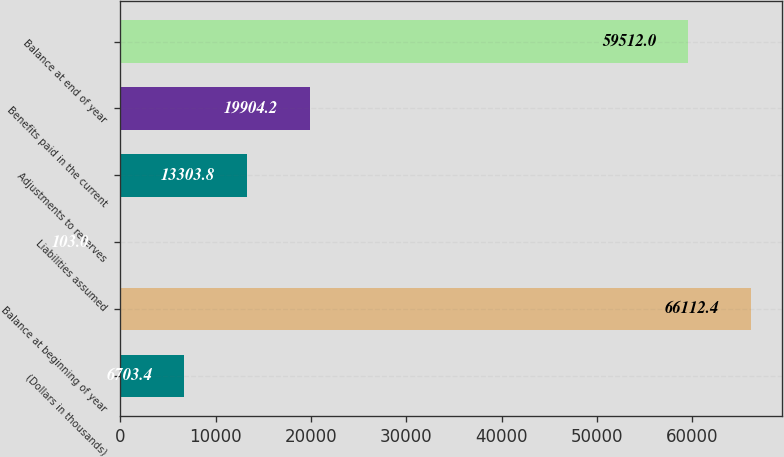Convert chart. <chart><loc_0><loc_0><loc_500><loc_500><bar_chart><fcel>(Dollars in thousands)<fcel>Balance at beginning of year<fcel>Liabilities assumed<fcel>Adjustments to reserves<fcel>Benefits paid in the current<fcel>Balance at end of year<nl><fcel>6703.4<fcel>66112.4<fcel>103<fcel>13303.8<fcel>19904.2<fcel>59512<nl></chart> 